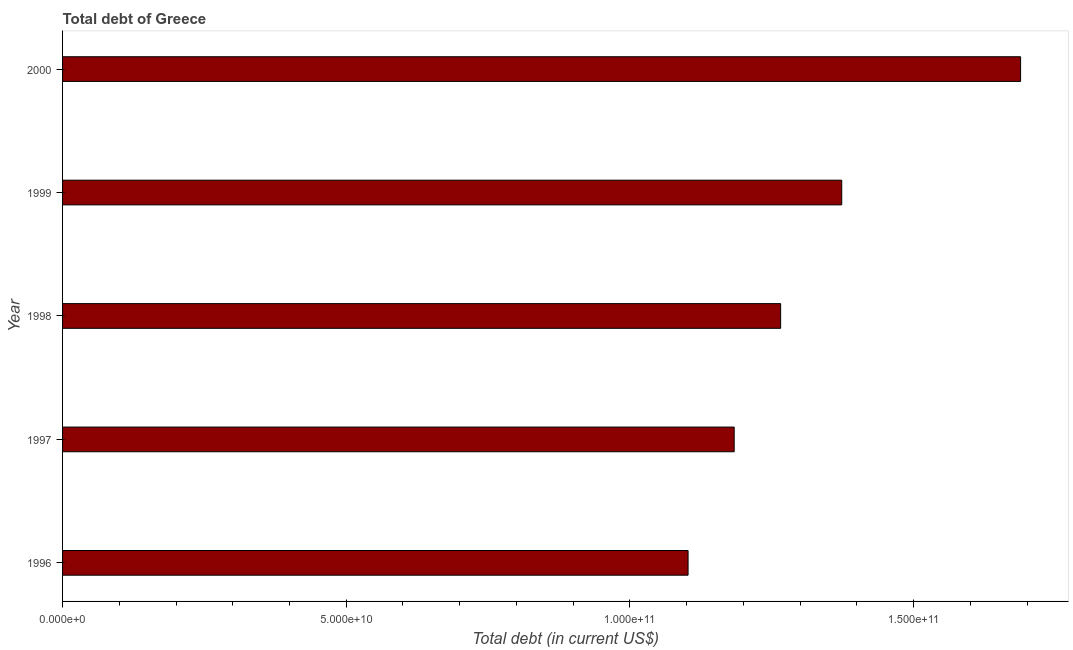Does the graph contain any zero values?
Offer a very short reply. No. What is the title of the graph?
Give a very brief answer. Total debt of Greece. What is the label or title of the X-axis?
Keep it short and to the point. Total debt (in current US$). What is the label or title of the Y-axis?
Offer a terse response. Year. What is the total debt in 2000?
Provide a succinct answer. 1.69e+11. Across all years, what is the maximum total debt?
Your answer should be compact. 1.69e+11. Across all years, what is the minimum total debt?
Make the answer very short. 1.10e+11. In which year was the total debt maximum?
Your response must be concise. 2000. In which year was the total debt minimum?
Provide a succinct answer. 1996. What is the sum of the total debt?
Offer a terse response. 6.61e+11. What is the difference between the total debt in 1998 and 1999?
Give a very brief answer. -1.08e+1. What is the average total debt per year?
Provide a short and direct response. 1.32e+11. What is the median total debt?
Your answer should be very brief. 1.27e+11. Do a majority of the years between 2000 and 1996 (inclusive) have total debt greater than 80000000000 US$?
Keep it short and to the point. Yes. What is the ratio of the total debt in 1996 to that in 2000?
Ensure brevity in your answer.  0.65. Is the difference between the total debt in 1997 and 1998 greater than the difference between any two years?
Ensure brevity in your answer.  No. What is the difference between the highest and the second highest total debt?
Ensure brevity in your answer.  3.15e+1. Is the sum of the total debt in 1996 and 1997 greater than the maximum total debt across all years?
Ensure brevity in your answer.  Yes. What is the difference between the highest and the lowest total debt?
Ensure brevity in your answer.  5.86e+1. How many years are there in the graph?
Provide a succinct answer. 5. What is the Total debt (in current US$) of 1996?
Offer a very short reply. 1.10e+11. What is the Total debt (in current US$) in 1997?
Ensure brevity in your answer.  1.18e+11. What is the Total debt (in current US$) of 1998?
Offer a very short reply. 1.27e+11. What is the Total debt (in current US$) in 1999?
Keep it short and to the point. 1.37e+11. What is the Total debt (in current US$) in 2000?
Provide a short and direct response. 1.69e+11. What is the difference between the Total debt (in current US$) in 1996 and 1997?
Provide a short and direct response. -8.13e+09. What is the difference between the Total debt (in current US$) in 1996 and 1998?
Your response must be concise. -1.63e+1. What is the difference between the Total debt (in current US$) in 1996 and 1999?
Offer a terse response. -2.71e+1. What is the difference between the Total debt (in current US$) in 1996 and 2000?
Give a very brief answer. -5.86e+1. What is the difference between the Total debt (in current US$) in 1997 and 1998?
Give a very brief answer. -8.19e+09. What is the difference between the Total debt (in current US$) in 1997 and 1999?
Make the answer very short. -1.90e+1. What is the difference between the Total debt (in current US$) in 1997 and 2000?
Keep it short and to the point. -5.05e+1. What is the difference between the Total debt (in current US$) in 1998 and 1999?
Provide a short and direct response. -1.08e+1. What is the difference between the Total debt (in current US$) in 1998 and 2000?
Keep it short and to the point. -4.23e+1. What is the difference between the Total debt (in current US$) in 1999 and 2000?
Provide a succinct answer. -3.15e+1. What is the ratio of the Total debt (in current US$) in 1996 to that in 1997?
Keep it short and to the point. 0.93. What is the ratio of the Total debt (in current US$) in 1996 to that in 1998?
Your answer should be very brief. 0.87. What is the ratio of the Total debt (in current US$) in 1996 to that in 1999?
Make the answer very short. 0.8. What is the ratio of the Total debt (in current US$) in 1996 to that in 2000?
Provide a succinct answer. 0.65. What is the ratio of the Total debt (in current US$) in 1997 to that in 1998?
Your answer should be compact. 0.94. What is the ratio of the Total debt (in current US$) in 1997 to that in 1999?
Your answer should be very brief. 0.86. What is the ratio of the Total debt (in current US$) in 1997 to that in 2000?
Keep it short and to the point. 0.7. What is the ratio of the Total debt (in current US$) in 1998 to that in 1999?
Keep it short and to the point. 0.92. What is the ratio of the Total debt (in current US$) in 1998 to that in 2000?
Your answer should be very brief. 0.75. What is the ratio of the Total debt (in current US$) in 1999 to that in 2000?
Provide a succinct answer. 0.81. 